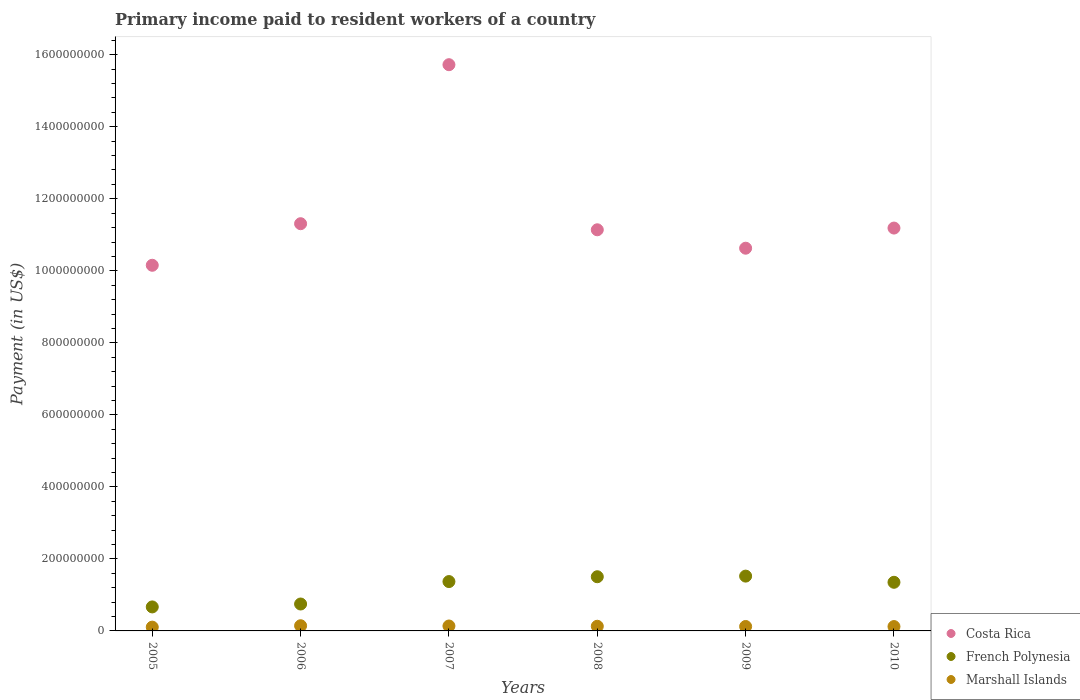How many different coloured dotlines are there?
Your answer should be very brief. 3. Is the number of dotlines equal to the number of legend labels?
Your answer should be very brief. Yes. What is the amount paid to workers in Marshall Islands in 2007?
Keep it short and to the point. 1.37e+07. Across all years, what is the maximum amount paid to workers in French Polynesia?
Your answer should be very brief. 1.52e+08. Across all years, what is the minimum amount paid to workers in Marshall Islands?
Make the answer very short. 1.05e+07. What is the total amount paid to workers in Costa Rica in the graph?
Give a very brief answer. 7.01e+09. What is the difference between the amount paid to workers in French Polynesia in 2005 and that in 2010?
Your answer should be compact. -6.84e+07. What is the difference between the amount paid to workers in Costa Rica in 2005 and the amount paid to workers in Marshall Islands in 2008?
Offer a very short reply. 1.00e+09. What is the average amount paid to workers in French Polynesia per year?
Keep it short and to the point. 1.19e+08. In the year 2006, what is the difference between the amount paid to workers in Costa Rica and amount paid to workers in French Polynesia?
Your answer should be very brief. 1.06e+09. In how many years, is the amount paid to workers in French Polynesia greater than 1480000000 US$?
Your answer should be very brief. 0. What is the ratio of the amount paid to workers in Costa Rica in 2005 to that in 2007?
Give a very brief answer. 0.65. Is the amount paid to workers in French Polynesia in 2005 less than that in 2010?
Provide a succinct answer. Yes. What is the difference between the highest and the second highest amount paid to workers in Marshall Islands?
Offer a very short reply. 6.94e+05. What is the difference between the highest and the lowest amount paid to workers in French Polynesia?
Your answer should be very brief. 8.56e+07. Is the sum of the amount paid to workers in Costa Rica in 2008 and 2009 greater than the maximum amount paid to workers in Marshall Islands across all years?
Make the answer very short. Yes. Is the amount paid to workers in Costa Rica strictly greater than the amount paid to workers in Marshall Islands over the years?
Offer a terse response. Yes. What is the difference between two consecutive major ticks on the Y-axis?
Give a very brief answer. 2.00e+08. Are the values on the major ticks of Y-axis written in scientific E-notation?
Give a very brief answer. No. Does the graph contain grids?
Offer a terse response. No. Where does the legend appear in the graph?
Keep it short and to the point. Bottom right. How many legend labels are there?
Provide a short and direct response. 3. How are the legend labels stacked?
Your answer should be very brief. Vertical. What is the title of the graph?
Offer a terse response. Primary income paid to resident workers of a country. What is the label or title of the Y-axis?
Your response must be concise. Payment (in US$). What is the Payment (in US$) of Costa Rica in 2005?
Keep it short and to the point. 1.02e+09. What is the Payment (in US$) of French Polynesia in 2005?
Offer a terse response. 6.66e+07. What is the Payment (in US$) of Marshall Islands in 2005?
Give a very brief answer. 1.05e+07. What is the Payment (in US$) of Costa Rica in 2006?
Your answer should be very brief. 1.13e+09. What is the Payment (in US$) in French Polynesia in 2006?
Your answer should be compact. 7.47e+07. What is the Payment (in US$) in Marshall Islands in 2006?
Your answer should be compact. 1.44e+07. What is the Payment (in US$) in Costa Rica in 2007?
Your response must be concise. 1.57e+09. What is the Payment (in US$) in French Polynesia in 2007?
Provide a succinct answer. 1.37e+08. What is the Payment (in US$) of Marshall Islands in 2007?
Your answer should be very brief. 1.37e+07. What is the Payment (in US$) in Costa Rica in 2008?
Give a very brief answer. 1.11e+09. What is the Payment (in US$) of French Polynesia in 2008?
Provide a succinct answer. 1.50e+08. What is the Payment (in US$) in Marshall Islands in 2008?
Provide a succinct answer. 1.29e+07. What is the Payment (in US$) in Costa Rica in 2009?
Ensure brevity in your answer.  1.06e+09. What is the Payment (in US$) of French Polynesia in 2009?
Your response must be concise. 1.52e+08. What is the Payment (in US$) in Marshall Islands in 2009?
Keep it short and to the point. 1.23e+07. What is the Payment (in US$) of Costa Rica in 2010?
Provide a succinct answer. 1.12e+09. What is the Payment (in US$) in French Polynesia in 2010?
Ensure brevity in your answer.  1.35e+08. What is the Payment (in US$) in Marshall Islands in 2010?
Your response must be concise. 1.21e+07. Across all years, what is the maximum Payment (in US$) of Costa Rica?
Give a very brief answer. 1.57e+09. Across all years, what is the maximum Payment (in US$) of French Polynesia?
Make the answer very short. 1.52e+08. Across all years, what is the maximum Payment (in US$) in Marshall Islands?
Offer a very short reply. 1.44e+07. Across all years, what is the minimum Payment (in US$) of Costa Rica?
Keep it short and to the point. 1.02e+09. Across all years, what is the minimum Payment (in US$) in French Polynesia?
Offer a very short reply. 6.66e+07. Across all years, what is the minimum Payment (in US$) in Marshall Islands?
Offer a terse response. 1.05e+07. What is the total Payment (in US$) of Costa Rica in the graph?
Offer a terse response. 7.01e+09. What is the total Payment (in US$) in French Polynesia in the graph?
Offer a terse response. 7.16e+08. What is the total Payment (in US$) of Marshall Islands in the graph?
Provide a succinct answer. 7.60e+07. What is the difference between the Payment (in US$) in Costa Rica in 2005 and that in 2006?
Keep it short and to the point. -1.15e+08. What is the difference between the Payment (in US$) of French Polynesia in 2005 and that in 2006?
Your answer should be compact. -8.10e+06. What is the difference between the Payment (in US$) of Marshall Islands in 2005 and that in 2006?
Keep it short and to the point. -3.86e+06. What is the difference between the Payment (in US$) in Costa Rica in 2005 and that in 2007?
Your response must be concise. -5.57e+08. What is the difference between the Payment (in US$) in French Polynesia in 2005 and that in 2007?
Keep it short and to the point. -7.04e+07. What is the difference between the Payment (in US$) in Marshall Islands in 2005 and that in 2007?
Offer a terse response. -3.17e+06. What is the difference between the Payment (in US$) in Costa Rica in 2005 and that in 2008?
Provide a short and direct response. -9.86e+07. What is the difference between the Payment (in US$) of French Polynesia in 2005 and that in 2008?
Your answer should be compact. -8.38e+07. What is the difference between the Payment (in US$) in Marshall Islands in 2005 and that in 2008?
Keep it short and to the point. -2.39e+06. What is the difference between the Payment (in US$) in Costa Rica in 2005 and that in 2009?
Offer a very short reply. -4.74e+07. What is the difference between the Payment (in US$) of French Polynesia in 2005 and that in 2009?
Offer a terse response. -8.56e+07. What is the difference between the Payment (in US$) in Marshall Islands in 2005 and that in 2009?
Your answer should be compact. -1.78e+06. What is the difference between the Payment (in US$) in Costa Rica in 2005 and that in 2010?
Offer a very short reply. -1.03e+08. What is the difference between the Payment (in US$) of French Polynesia in 2005 and that in 2010?
Provide a succinct answer. -6.84e+07. What is the difference between the Payment (in US$) of Marshall Islands in 2005 and that in 2010?
Make the answer very short. -1.57e+06. What is the difference between the Payment (in US$) in Costa Rica in 2006 and that in 2007?
Keep it short and to the point. -4.42e+08. What is the difference between the Payment (in US$) in French Polynesia in 2006 and that in 2007?
Make the answer very short. -6.23e+07. What is the difference between the Payment (in US$) in Marshall Islands in 2006 and that in 2007?
Your response must be concise. 6.94e+05. What is the difference between the Payment (in US$) of Costa Rica in 2006 and that in 2008?
Offer a very short reply. 1.69e+07. What is the difference between the Payment (in US$) of French Polynesia in 2006 and that in 2008?
Your answer should be compact. -7.57e+07. What is the difference between the Payment (in US$) in Marshall Islands in 2006 and that in 2008?
Keep it short and to the point. 1.47e+06. What is the difference between the Payment (in US$) in Costa Rica in 2006 and that in 2009?
Your response must be concise. 6.80e+07. What is the difference between the Payment (in US$) of French Polynesia in 2006 and that in 2009?
Your answer should be compact. -7.75e+07. What is the difference between the Payment (in US$) in Marshall Islands in 2006 and that in 2009?
Offer a very short reply. 2.08e+06. What is the difference between the Payment (in US$) of Costa Rica in 2006 and that in 2010?
Your response must be concise. 1.21e+07. What is the difference between the Payment (in US$) in French Polynesia in 2006 and that in 2010?
Provide a succinct answer. -6.03e+07. What is the difference between the Payment (in US$) of Marshall Islands in 2006 and that in 2010?
Make the answer very short. 2.29e+06. What is the difference between the Payment (in US$) of Costa Rica in 2007 and that in 2008?
Provide a short and direct response. 4.58e+08. What is the difference between the Payment (in US$) in French Polynesia in 2007 and that in 2008?
Make the answer very short. -1.34e+07. What is the difference between the Payment (in US$) in Marshall Islands in 2007 and that in 2008?
Your answer should be compact. 7.72e+05. What is the difference between the Payment (in US$) of Costa Rica in 2007 and that in 2009?
Give a very brief answer. 5.10e+08. What is the difference between the Payment (in US$) in French Polynesia in 2007 and that in 2009?
Give a very brief answer. -1.52e+07. What is the difference between the Payment (in US$) of Marshall Islands in 2007 and that in 2009?
Offer a very short reply. 1.39e+06. What is the difference between the Payment (in US$) of Costa Rica in 2007 and that in 2010?
Your response must be concise. 4.54e+08. What is the difference between the Payment (in US$) in French Polynesia in 2007 and that in 2010?
Provide a short and direct response. 2.00e+06. What is the difference between the Payment (in US$) in Marshall Islands in 2007 and that in 2010?
Offer a very short reply. 1.59e+06. What is the difference between the Payment (in US$) in Costa Rica in 2008 and that in 2009?
Provide a succinct answer. 5.12e+07. What is the difference between the Payment (in US$) in French Polynesia in 2008 and that in 2009?
Provide a succinct answer. -1.75e+06. What is the difference between the Payment (in US$) of Marshall Islands in 2008 and that in 2009?
Your answer should be very brief. 6.16e+05. What is the difference between the Payment (in US$) of Costa Rica in 2008 and that in 2010?
Your answer should be very brief. -4.78e+06. What is the difference between the Payment (in US$) in French Polynesia in 2008 and that in 2010?
Your answer should be very brief. 1.54e+07. What is the difference between the Payment (in US$) of Marshall Islands in 2008 and that in 2010?
Your response must be concise. 8.22e+05. What is the difference between the Payment (in US$) of Costa Rica in 2009 and that in 2010?
Offer a very short reply. -5.59e+07. What is the difference between the Payment (in US$) of French Polynesia in 2009 and that in 2010?
Your response must be concise. 1.72e+07. What is the difference between the Payment (in US$) of Marshall Islands in 2009 and that in 2010?
Your answer should be very brief. 2.06e+05. What is the difference between the Payment (in US$) in Costa Rica in 2005 and the Payment (in US$) in French Polynesia in 2006?
Your response must be concise. 9.41e+08. What is the difference between the Payment (in US$) of Costa Rica in 2005 and the Payment (in US$) of Marshall Islands in 2006?
Offer a terse response. 1.00e+09. What is the difference between the Payment (in US$) of French Polynesia in 2005 and the Payment (in US$) of Marshall Islands in 2006?
Offer a very short reply. 5.22e+07. What is the difference between the Payment (in US$) of Costa Rica in 2005 and the Payment (in US$) of French Polynesia in 2007?
Ensure brevity in your answer.  8.78e+08. What is the difference between the Payment (in US$) in Costa Rica in 2005 and the Payment (in US$) in Marshall Islands in 2007?
Offer a very short reply. 1.00e+09. What is the difference between the Payment (in US$) in French Polynesia in 2005 and the Payment (in US$) in Marshall Islands in 2007?
Provide a succinct answer. 5.29e+07. What is the difference between the Payment (in US$) in Costa Rica in 2005 and the Payment (in US$) in French Polynesia in 2008?
Offer a very short reply. 8.65e+08. What is the difference between the Payment (in US$) in Costa Rica in 2005 and the Payment (in US$) in Marshall Islands in 2008?
Provide a short and direct response. 1.00e+09. What is the difference between the Payment (in US$) of French Polynesia in 2005 and the Payment (in US$) of Marshall Islands in 2008?
Provide a short and direct response. 5.37e+07. What is the difference between the Payment (in US$) in Costa Rica in 2005 and the Payment (in US$) in French Polynesia in 2009?
Give a very brief answer. 8.63e+08. What is the difference between the Payment (in US$) in Costa Rica in 2005 and the Payment (in US$) in Marshall Islands in 2009?
Give a very brief answer. 1.00e+09. What is the difference between the Payment (in US$) in French Polynesia in 2005 and the Payment (in US$) in Marshall Islands in 2009?
Offer a very short reply. 5.43e+07. What is the difference between the Payment (in US$) in Costa Rica in 2005 and the Payment (in US$) in French Polynesia in 2010?
Make the answer very short. 8.80e+08. What is the difference between the Payment (in US$) of Costa Rica in 2005 and the Payment (in US$) of Marshall Islands in 2010?
Offer a very short reply. 1.00e+09. What is the difference between the Payment (in US$) of French Polynesia in 2005 and the Payment (in US$) of Marshall Islands in 2010?
Provide a succinct answer. 5.45e+07. What is the difference between the Payment (in US$) of Costa Rica in 2006 and the Payment (in US$) of French Polynesia in 2007?
Give a very brief answer. 9.94e+08. What is the difference between the Payment (in US$) of Costa Rica in 2006 and the Payment (in US$) of Marshall Islands in 2007?
Provide a succinct answer. 1.12e+09. What is the difference between the Payment (in US$) of French Polynesia in 2006 and the Payment (in US$) of Marshall Islands in 2007?
Your answer should be compact. 6.10e+07. What is the difference between the Payment (in US$) of Costa Rica in 2006 and the Payment (in US$) of French Polynesia in 2008?
Ensure brevity in your answer.  9.80e+08. What is the difference between the Payment (in US$) of Costa Rica in 2006 and the Payment (in US$) of Marshall Islands in 2008?
Keep it short and to the point. 1.12e+09. What is the difference between the Payment (in US$) of French Polynesia in 2006 and the Payment (in US$) of Marshall Islands in 2008?
Provide a succinct answer. 6.18e+07. What is the difference between the Payment (in US$) in Costa Rica in 2006 and the Payment (in US$) in French Polynesia in 2009?
Make the answer very short. 9.79e+08. What is the difference between the Payment (in US$) in Costa Rica in 2006 and the Payment (in US$) in Marshall Islands in 2009?
Offer a terse response. 1.12e+09. What is the difference between the Payment (in US$) in French Polynesia in 2006 and the Payment (in US$) in Marshall Islands in 2009?
Give a very brief answer. 6.24e+07. What is the difference between the Payment (in US$) in Costa Rica in 2006 and the Payment (in US$) in French Polynesia in 2010?
Ensure brevity in your answer.  9.96e+08. What is the difference between the Payment (in US$) of Costa Rica in 2006 and the Payment (in US$) of Marshall Islands in 2010?
Make the answer very short. 1.12e+09. What is the difference between the Payment (in US$) in French Polynesia in 2006 and the Payment (in US$) in Marshall Islands in 2010?
Provide a short and direct response. 6.26e+07. What is the difference between the Payment (in US$) of Costa Rica in 2007 and the Payment (in US$) of French Polynesia in 2008?
Give a very brief answer. 1.42e+09. What is the difference between the Payment (in US$) of Costa Rica in 2007 and the Payment (in US$) of Marshall Islands in 2008?
Offer a terse response. 1.56e+09. What is the difference between the Payment (in US$) of French Polynesia in 2007 and the Payment (in US$) of Marshall Islands in 2008?
Offer a terse response. 1.24e+08. What is the difference between the Payment (in US$) of Costa Rica in 2007 and the Payment (in US$) of French Polynesia in 2009?
Give a very brief answer. 1.42e+09. What is the difference between the Payment (in US$) in Costa Rica in 2007 and the Payment (in US$) in Marshall Islands in 2009?
Keep it short and to the point. 1.56e+09. What is the difference between the Payment (in US$) of French Polynesia in 2007 and the Payment (in US$) of Marshall Islands in 2009?
Keep it short and to the point. 1.25e+08. What is the difference between the Payment (in US$) in Costa Rica in 2007 and the Payment (in US$) in French Polynesia in 2010?
Offer a very short reply. 1.44e+09. What is the difference between the Payment (in US$) in Costa Rica in 2007 and the Payment (in US$) in Marshall Islands in 2010?
Give a very brief answer. 1.56e+09. What is the difference between the Payment (in US$) of French Polynesia in 2007 and the Payment (in US$) of Marshall Islands in 2010?
Your answer should be very brief. 1.25e+08. What is the difference between the Payment (in US$) in Costa Rica in 2008 and the Payment (in US$) in French Polynesia in 2009?
Provide a succinct answer. 9.62e+08. What is the difference between the Payment (in US$) of Costa Rica in 2008 and the Payment (in US$) of Marshall Islands in 2009?
Keep it short and to the point. 1.10e+09. What is the difference between the Payment (in US$) in French Polynesia in 2008 and the Payment (in US$) in Marshall Islands in 2009?
Make the answer very short. 1.38e+08. What is the difference between the Payment (in US$) of Costa Rica in 2008 and the Payment (in US$) of French Polynesia in 2010?
Give a very brief answer. 9.79e+08. What is the difference between the Payment (in US$) of Costa Rica in 2008 and the Payment (in US$) of Marshall Islands in 2010?
Your answer should be very brief. 1.10e+09. What is the difference between the Payment (in US$) in French Polynesia in 2008 and the Payment (in US$) in Marshall Islands in 2010?
Offer a terse response. 1.38e+08. What is the difference between the Payment (in US$) of Costa Rica in 2009 and the Payment (in US$) of French Polynesia in 2010?
Ensure brevity in your answer.  9.28e+08. What is the difference between the Payment (in US$) in Costa Rica in 2009 and the Payment (in US$) in Marshall Islands in 2010?
Ensure brevity in your answer.  1.05e+09. What is the difference between the Payment (in US$) in French Polynesia in 2009 and the Payment (in US$) in Marshall Islands in 2010?
Keep it short and to the point. 1.40e+08. What is the average Payment (in US$) of Costa Rica per year?
Make the answer very short. 1.17e+09. What is the average Payment (in US$) in French Polynesia per year?
Provide a short and direct response. 1.19e+08. What is the average Payment (in US$) of Marshall Islands per year?
Your answer should be very brief. 1.27e+07. In the year 2005, what is the difference between the Payment (in US$) in Costa Rica and Payment (in US$) in French Polynesia?
Your answer should be very brief. 9.49e+08. In the year 2005, what is the difference between the Payment (in US$) in Costa Rica and Payment (in US$) in Marshall Islands?
Give a very brief answer. 1.00e+09. In the year 2005, what is the difference between the Payment (in US$) of French Polynesia and Payment (in US$) of Marshall Islands?
Give a very brief answer. 5.61e+07. In the year 2006, what is the difference between the Payment (in US$) in Costa Rica and Payment (in US$) in French Polynesia?
Your answer should be compact. 1.06e+09. In the year 2006, what is the difference between the Payment (in US$) in Costa Rica and Payment (in US$) in Marshall Islands?
Provide a succinct answer. 1.12e+09. In the year 2006, what is the difference between the Payment (in US$) of French Polynesia and Payment (in US$) of Marshall Islands?
Provide a succinct answer. 6.03e+07. In the year 2007, what is the difference between the Payment (in US$) of Costa Rica and Payment (in US$) of French Polynesia?
Make the answer very short. 1.44e+09. In the year 2007, what is the difference between the Payment (in US$) of Costa Rica and Payment (in US$) of Marshall Islands?
Ensure brevity in your answer.  1.56e+09. In the year 2007, what is the difference between the Payment (in US$) in French Polynesia and Payment (in US$) in Marshall Islands?
Your answer should be compact. 1.23e+08. In the year 2008, what is the difference between the Payment (in US$) of Costa Rica and Payment (in US$) of French Polynesia?
Provide a short and direct response. 9.63e+08. In the year 2008, what is the difference between the Payment (in US$) in Costa Rica and Payment (in US$) in Marshall Islands?
Your response must be concise. 1.10e+09. In the year 2008, what is the difference between the Payment (in US$) in French Polynesia and Payment (in US$) in Marshall Islands?
Give a very brief answer. 1.38e+08. In the year 2009, what is the difference between the Payment (in US$) in Costa Rica and Payment (in US$) in French Polynesia?
Make the answer very short. 9.11e+08. In the year 2009, what is the difference between the Payment (in US$) of Costa Rica and Payment (in US$) of Marshall Islands?
Your answer should be very brief. 1.05e+09. In the year 2009, what is the difference between the Payment (in US$) of French Polynesia and Payment (in US$) of Marshall Islands?
Your answer should be compact. 1.40e+08. In the year 2010, what is the difference between the Payment (in US$) in Costa Rica and Payment (in US$) in French Polynesia?
Offer a very short reply. 9.84e+08. In the year 2010, what is the difference between the Payment (in US$) of Costa Rica and Payment (in US$) of Marshall Islands?
Give a very brief answer. 1.11e+09. In the year 2010, what is the difference between the Payment (in US$) in French Polynesia and Payment (in US$) in Marshall Islands?
Keep it short and to the point. 1.23e+08. What is the ratio of the Payment (in US$) in Costa Rica in 2005 to that in 2006?
Give a very brief answer. 0.9. What is the ratio of the Payment (in US$) in French Polynesia in 2005 to that in 2006?
Offer a very short reply. 0.89. What is the ratio of the Payment (in US$) in Marshall Islands in 2005 to that in 2006?
Provide a short and direct response. 0.73. What is the ratio of the Payment (in US$) of Costa Rica in 2005 to that in 2007?
Your response must be concise. 0.65. What is the ratio of the Payment (in US$) in French Polynesia in 2005 to that in 2007?
Your answer should be very brief. 0.49. What is the ratio of the Payment (in US$) of Marshall Islands in 2005 to that in 2007?
Give a very brief answer. 0.77. What is the ratio of the Payment (in US$) of Costa Rica in 2005 to that in 2008?
Ensure brevity in your answer.  0.91. What is the ratio of the Payment (in US$) in French Polynesia in 2005 to that in 2008?
Give a very brief answer. 0.44. What is the ratio of the Payment (in US$) of Marshall Islands in 2005 to that in 2008?
Provide a short and direct response. 0.81. What is the ratio of the Payment (in US$) of Costa Rica in 2005 to that in 2009?
Offer a terse response. 0.96. What is the ratio of the Payment (in US$) in French Polynesia in 2005 to that in 2009?
Your response must be concise. 0.44. What is the ratio of the Payment (in US$) of Marshall Islands in 2005 to that in 2009?
Keep it short and to the point. 0.86. What is the ratio of the Payment (in US$) of Costa Rica in 2005 to that in 2010?
Make the answer very short. 0.91. What is the ratio of the Payment (in US$) of French Polynesia in 2005 to that in 2010?
Offer a very short reply. 0.49. What is the ratio of the Payment (in US$) of Marshall Islands in 2005 to that in 2010?
Make the answer very short. 0.87. What is the ratio of the Payment (in US$) in Costa Rica in 2006 to that in 2007?
Your answer should be compact. 0.72. What is the ratio of the Payment (in US$) of French Polynesia in 2006 to that in 2007?
Offer a terse response. 0.55. What is the ratio of the Payment (in US$) of Marshall Islands in 2006 to that in 2007?
Keep it short and to the point. 1.05. What is the ratio of the Payment (in US$) of Costa Rica in 2006 to that in 2008?
Keep it short and to the point. 1.02. What is the ratio of the Payment (in US$) in French Polynesia in 2006 to that in 2008?
Provide a short and direct response. 0.5. What is the ratio of the Payment (in US$) in Marshall Islands in 2006 to that in 2008?
Provide a short and direct response. 1.11. What is the ratio of the Payment (in US$) in Costa Rica in 2006 to that in 2009?
Offer a terse response. 1.06. What is the ratio of the Payment (in US$) in French Polynesia in 2006 to that in 2009?
Keep it short and to the point. 0.49. What is the ratio of the Payment (in US$) in Marshall Islands in 2006 to that in 2009?
Ensure brevity in your answer.  1.17. What is the ratio of the Payment (in US$) of Costa Rica in 2006 to that in 2010?
Make the answer very short. 1.01. What is the ratio of the Payment (in US$) in French Polynesia in 2006 to that in 2010?
Offer a terse response. 0.55. What is the ratio of the Payment (in US$) in Marshall Islands in 2006 to that in 2010?
Offer a terse response. 1.19. What is the ratio of the Payment (in US$) of Costa Rica in 2007 to that in 2008?
Give a very brief answer. 1.41. What is the ratio of the Payment (in US$) of French Polynesia in 2007 to that in 2008?
Offer a very short reply. 0.91. What is the ratio of the Payment (in US$) of Marshall Islands in 2007 to that in 2008?
Offer a very short reply. 1.06. What is the ratio of the Payment (in US$) in Costa Rica in 2007 to that in 2009?
Give a very brief answer. 1.48. What is the ratio of the Payment (in US$) in French Polynesia in 2007 to that in 2009?
Your answer should be compact. 0.9. What is the ratio of the Payment (in US$) in Marshall Islands in 2007 to that in 2009?
Your response must be concise. 1.11. What is the ratio of the Payment (in US$) in Costa Rica in 2007 to that in 2010?
Offer a very short reply. 1.41. What is the ratio of the Payment (in US$) in French Polynesia in 2007 to that in 2010?
Your response must be concise. 1.01. What is the ratio of the Payment (in US$) of Marshall Islands in 2007 to that in 2010?
Offer a terse response. 1.13. What is the ratio of the Payment (in US$) of Costa Rica in 2008 to that in 2009?
Provide a short and direct response. 1.05. What is the ratio of the Payment (in US$) of French Polynesia in 2008 to that in 2009?
Your answer should be very brief. 0.99. What is the ratio of the Payment (in US$) of Marshall Islands in 2008 to that in 2009?
Offer a terse response. 1.05. What is the ratio of the Payment (in US$) of Costa Rica in 2008 to that in 2010?
Your response must be concise. 1. What is the ratio of the Payment (in US$) in French Polynesia in 2008 to that in 2010?
Offer a very short reply. 1.11. What is the ratio of the Payment (in US$) in Marshall Islands in 2008 to that in 2010?
Give a very brief answer. 1.07. What is the ratio of the Payment (in US$) of French Polynesia in 2009 to that in 2010?
Ensure brevity in your answer.  1.13. What is the ratio of the Payment (in US$) in Marshall Islands in 2009 to that in 2010?
Your response must be concise. 1.02. What is the difference between the highest and the second highest Payment (in US$) of Costa Rica?
Offer a terse response. 4.42e+08. What is the difference between the highest and the second highest Payment (in US$) of French Polynesia?
Give a very brief answer. 1.75e+06. What is the difference between the highest and the second highest Payment (in US$) of Marshall Islands?
Your response must be concise. 6.94e+05. What is the difference between the highest and the lowest Payment (in US$) of Costa Rica?
Your answer should be very brief. 5.57e+08. What is the difference between the highest and the lowest Payment (in US$) in French Polynesia?
Provide a short and direct response. 8.56e+07. What is the difference between the highest and the lowest Payment (in US$) in Marshall Islands?
Your response must be concise. 3.86e+06. 